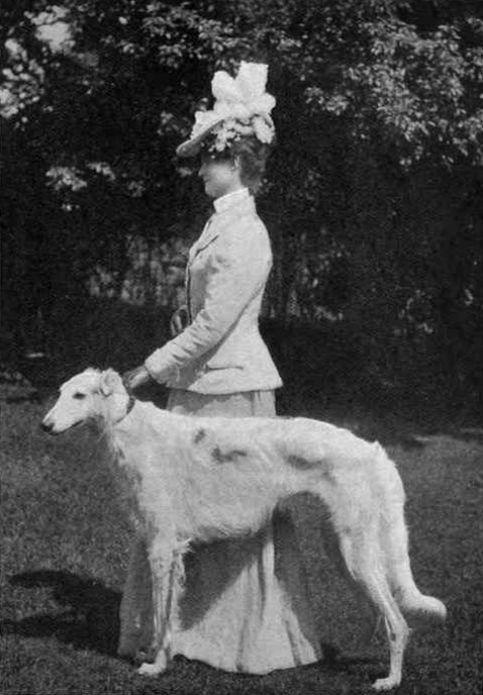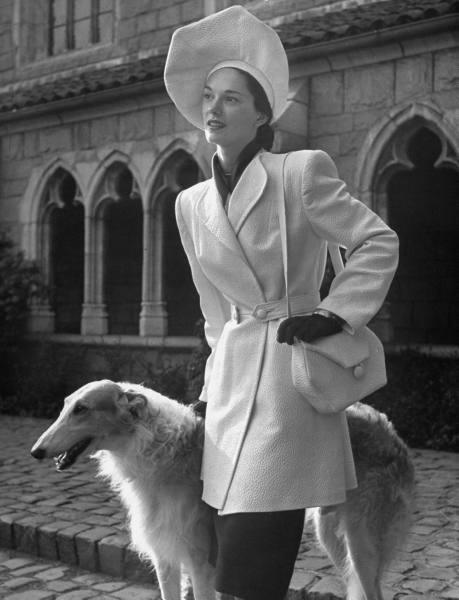The first image is the image on the left, the second image is the image on the right. Examine the images to the left and right. Is the description "There are only two dogs." accurate? Answer yes or no. Yes. 